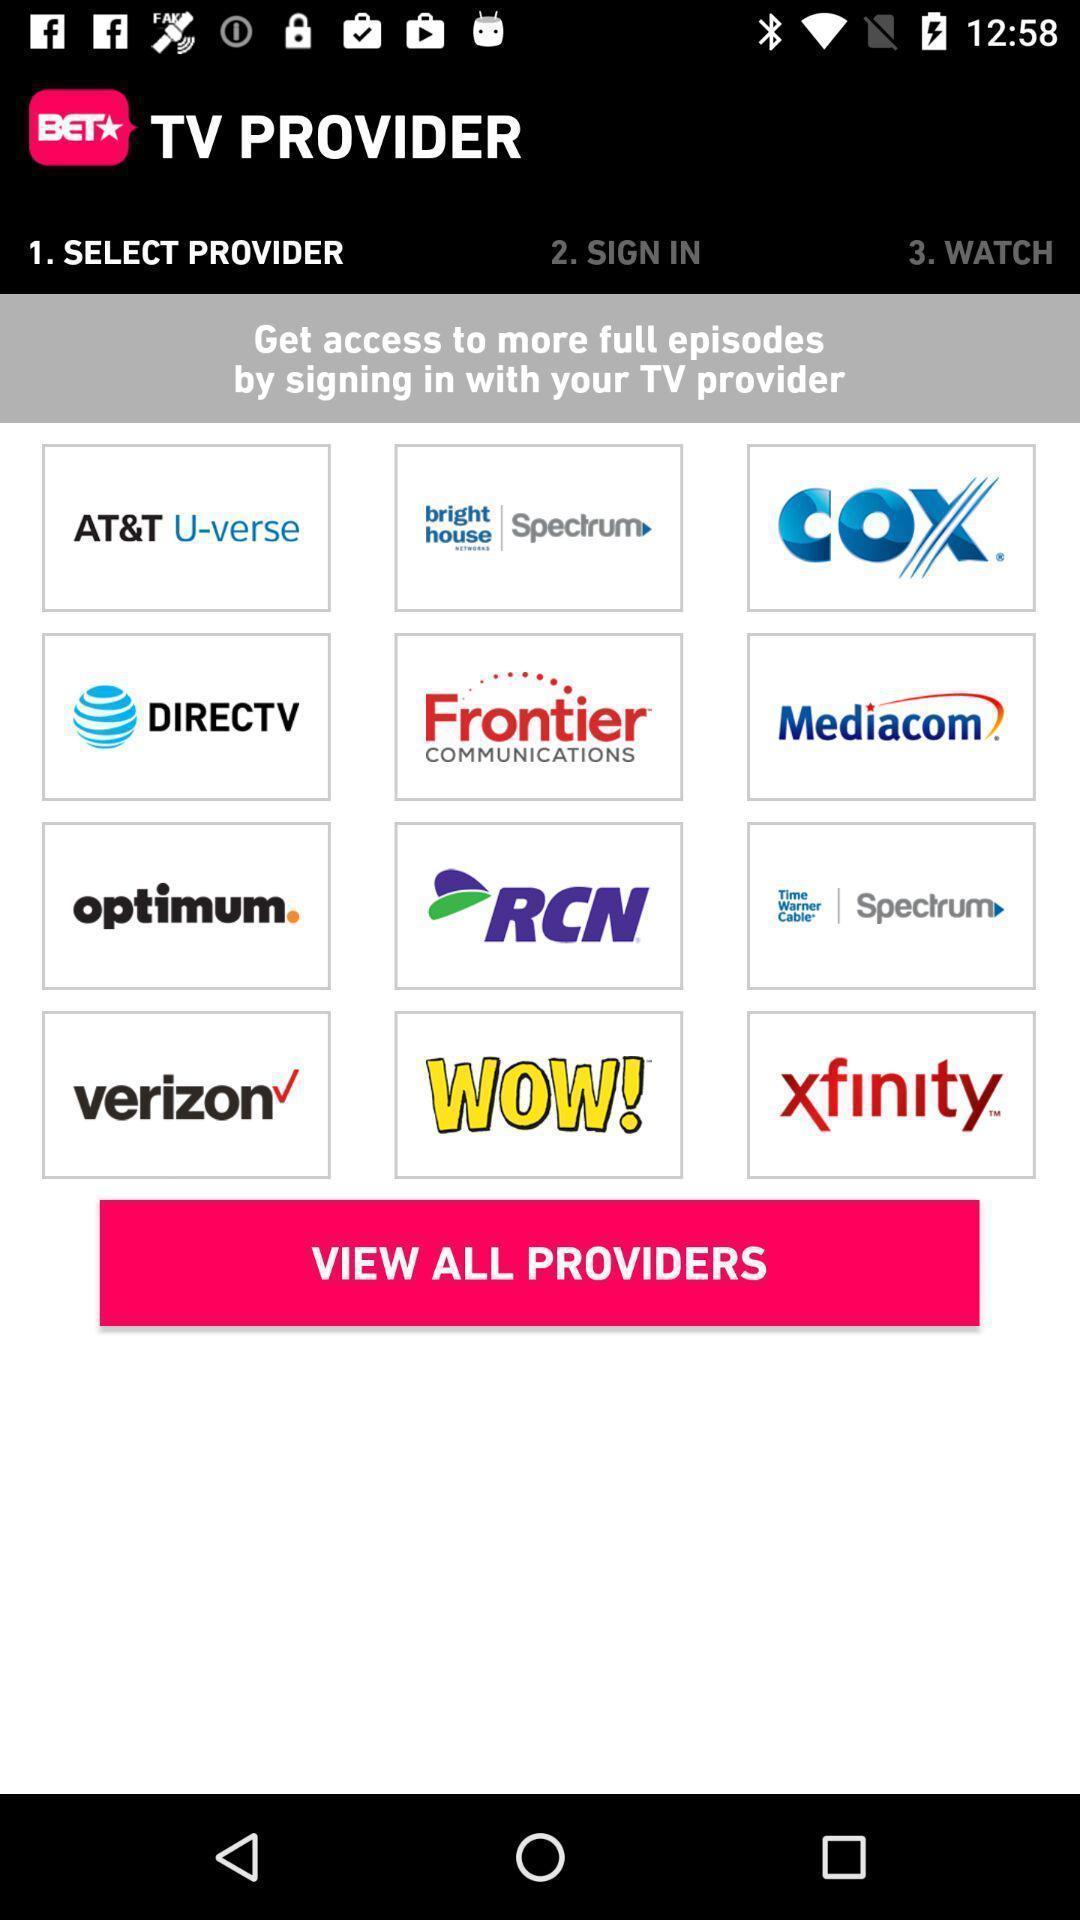Describe the content in this image. Page displaying with different providers for television. 